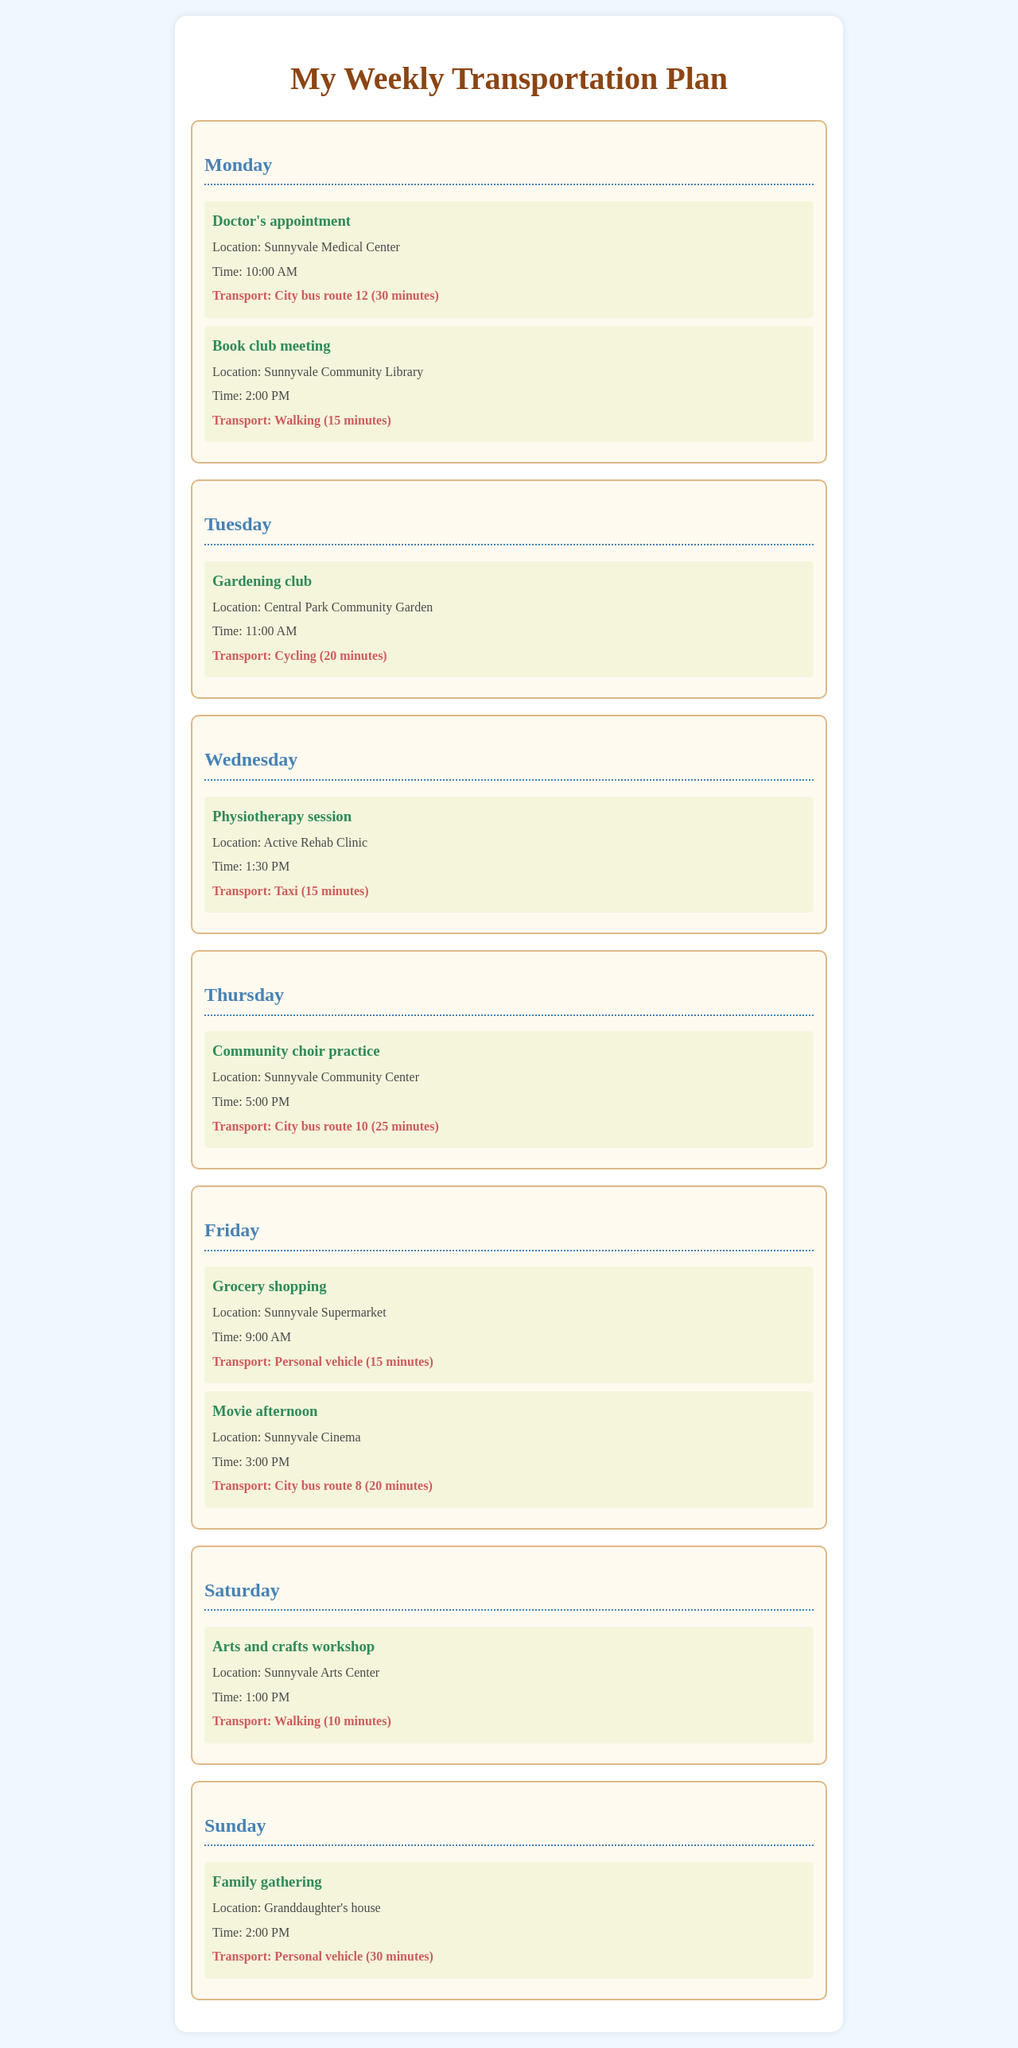What is the first appointment on Monday? The first appointment listed for Monday is a Doctor's appointment at 10:00 AM.
Answer: Doctor's appointment What transport is used for grocery shopping? The document specifies the mode of transport for grocery shopping is a personal vehicle.
Answer: Personal vehicle How long is the transport for the physiotherapy session? The transport time for the physiotherapy session is mentioned as 15 minutes in the document.
Answer: 15 minutes On which day is the community choir practice scheduled? The document indicates that the community choir practice is scheduled for Thursday.
Answer: Thursday What is the location of the arts and crafts workshop? The document states that the location of the arts and crafts workshop is the Sunnyvale Arts Center.
Answer: Sunnyvale Arts Center How many activities are scheduled for Friday? There are two activities scheduled for Friday as outlined in the document.
Answer: 2 What time does the family gathering take place? The document notes that the family gathering is set for 2:00 PM on Sunday.
Answer: 2:00 PM Which city bus route is used for the movie afternoon? The document specifies that City bus route 8 is used for the movie afternoon.
Answer: City bus route 8 What is the time of the gardening club meeting? The gardening club meeting is scheduled for 11:00 AM as indicated in the document.
Answer: 11:00 AM 